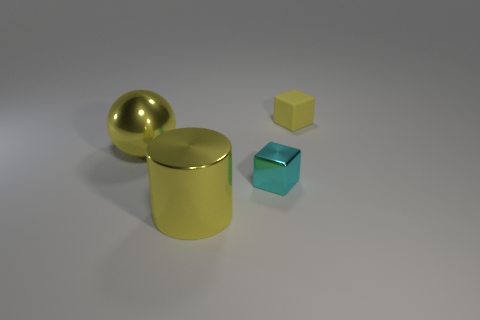Does the block that is behind the cyan object have the same color as the sphere in front of the matte block?
Give a very brief answer. Yes. Is there any other thing of the same color as the tiny matte thing?
Give a very brief answer. Yes. There is a cylinder that is the same color as the rubber cube; what is its size?
Offer a terse response. Large. How many shiny things have the same color as the metal sphere?
Provide a succinct answer. 1. What number of objects are metal things in front of the cyan metallic object or cyan things?
Your response must be concise. 2. Is the cyan thing made of the same material as the ball to the left of the small yellow cube?
Ensure brevity in your answer.  Yes. What is the shape of the big yellow shiny object behind the small block in front of the big shiny sphere?
Offer a very short reply. Sphere. There is a cylinder; is it the same color as the object that is behind the large yellow shiny sphere?
Your answer should be compact. Yes. Is there any other thing that has the same material as the yellow block?
Give a very brief answer. No. What shape is the small cyan metallic thing?
Your answer should be very brief. Cube. 